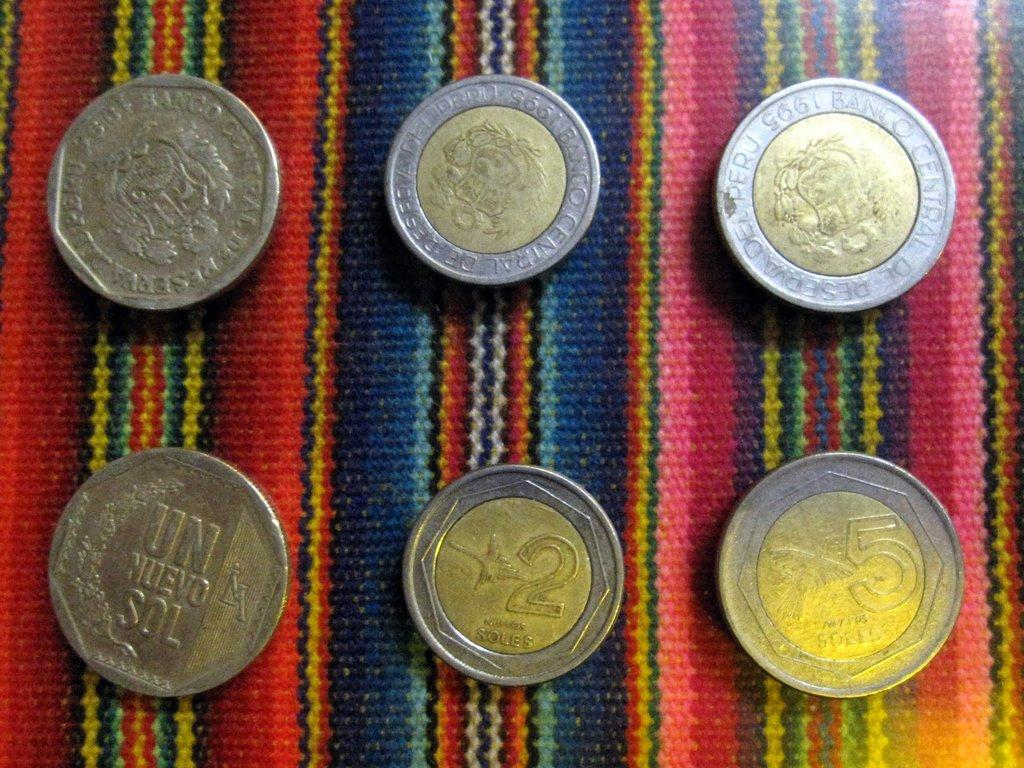How many coins are present in the image? There are six coins in the image. Can you describe anything visible in the background of the image? There is a cloth visible in the background of the image. What type of bag is being crushed by the coins in the image? There is no bag present in the image, and the coins are not crushing anything. 